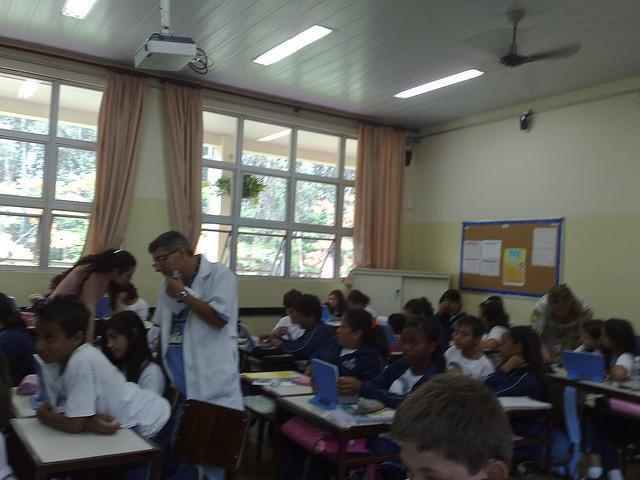How many people have red shirts on?
Give a very brief answer. 0. How many people are visible?
Give a very brief answer. 10. How many skateboard wheels can you see?
Give a very brief answer. 0. 